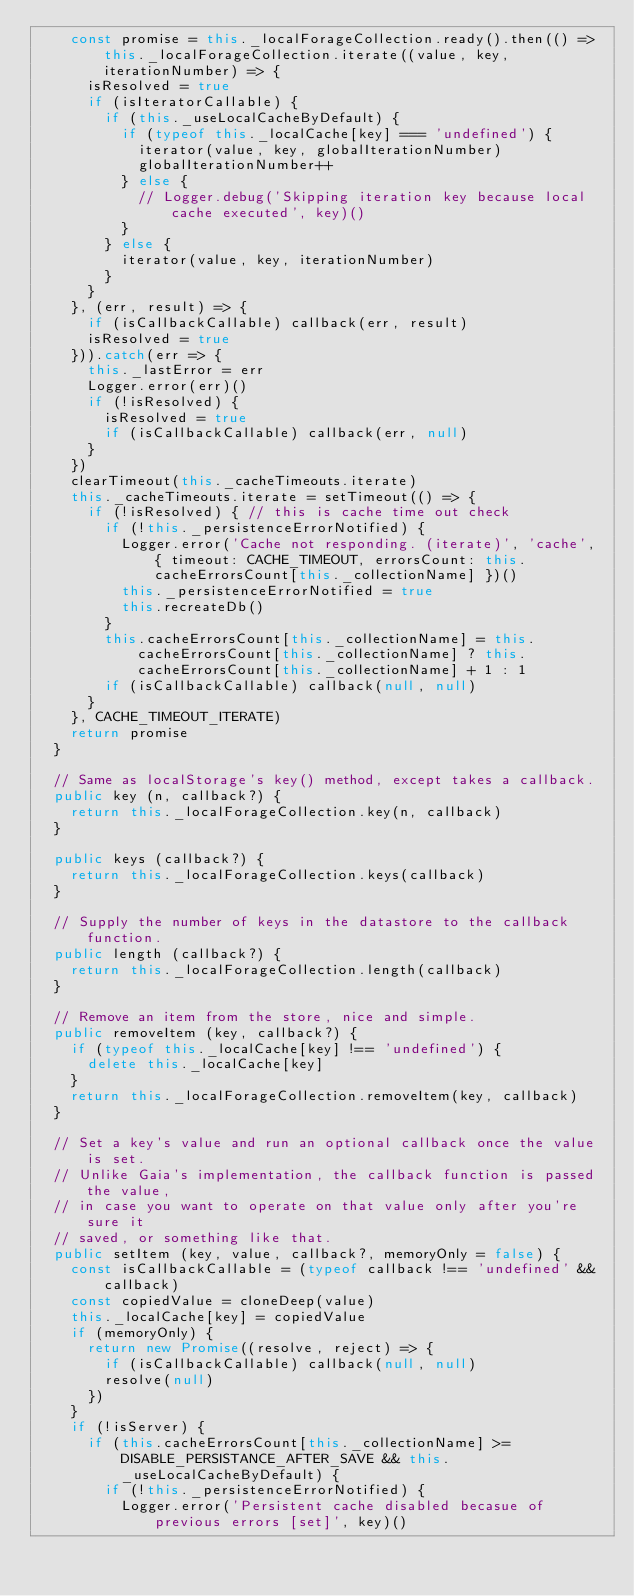Convert code to text. <code><loc_0><loc_0><loc_500><loc_500><_TypeScript_>    const promise = this._localForageCollection.ready().then(() => this._localForageCollection.iterate((value, key, iterationNumber) => {
      isResolved = true
      if (isIteratorCallable) {
        if (this._useLocalCacheByDefault) {
          if (typeof this._localCache[key] === 'undefined') {
            iterator(value, key, globalIterationNumber)
            globalIterationNumber++
          } else {
            // Logger.debug('Skipping iteration key because local cache executed', key)()
          }
        } else {
          iterator(value, key, iterationNumber)
        }
      }
    }, (err, result) => {
      if (isCallbackCallable) callback(err, result)
      isResolved = true
    })).catch(err => {
      this._lastError = err
      Logger.error(err)()
      if (!isResolved) {
        isResolved = true
        if (isCallbackCallable) callback(err, null)
      }
    })
    clearTimeout(this._cacheTimeouts.iterate)
    this._cacheTimeouts.iterate = setTimeout(() => {
      if (!isResolved) { // this is cache time out check
        if (!this._persistenceErrorNotified) {
          Logger.error('Cache not responding. (iterate)', 'cache', { timeout: CACHE_TIMEOUT, errorsCount: this.cacheErrorsCount[this._collectionName] })()
          this._persistenceErrorNotified = true
          this.recreateDb()
        }
        this.cacheErrorsCount[this._collectionName] = this.cacheErrorsCount[this._collectionName] ? this.cacheErrorsCount[this._collectionName] + 1 : 1
        if (isCallbackCallable) callback(null, null)
      }
    }, CACHE_TIMEOUT_ITERATE)
    return promise
  }

  // Same as localStorage's key() method, except takes a callback.
  public key (n, callback?) {
    return this._localForageCollection.key(n, callback)
  }

  public keys (callback?) {
    return this._localForageCollection.keys(callback)
  }

  // Supply the number of keys in the datastore to the callback function.
  public length (callback?) {
    return this._localForageCollection.length(callback)
  }

  // Remove an item from the store, nice and simple.
  public removeItem (key, callback?) {
    if (typeof this._localCache[key] !== 'undefined') {
      delete this._localCache[key]
    }
    return this._localForageCollection.removeItem(key, callback)
  }

  // Set a key's value and run an optional callback once the value is set.
  // Unlike Gaia's implementation, the callback function is passed the value,
  // in case you want to operate on that value only after you're sure it
  // saved, or something like that.
  public setItem (key, value, callback?, memoryOnly = false) {
    const isCallbackCallable = (typeof callback !== 'undefined' && callback)
    const copiedValue = cloneDeep(value)
    this._localCache[key] = copiedValue
    if (memoryOnly) {
      return new Promise((resolve, reject) => {
        if (isCallbackCallable) callback(null, null)
        resolve(null)
      })
    }
    if (!isServer) {
      if (this.cacheErrorsCount[this._collectionName] >= DISABLE_PERSISTANCE_AFTER_SAVE && this._useLocalCacheByDefault) {
        if (!this._persistenceErrorNotified) {
          Logger.error('Persistent cache disabled becasue of previous errors [set]', key)()</code> 